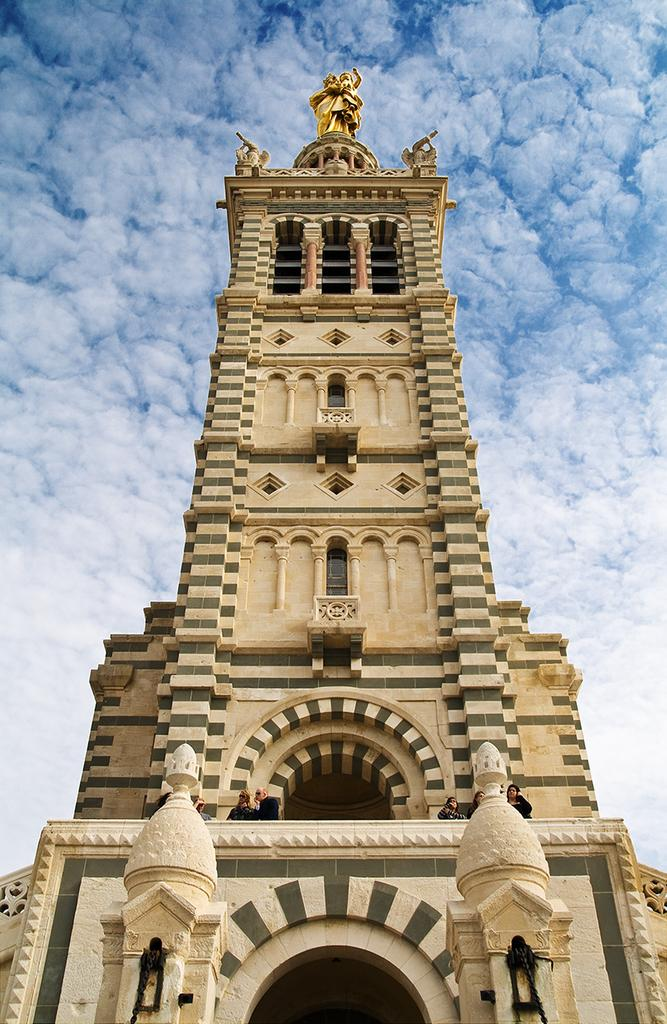What is the main structure in the image? There is a building in the middle of the image. What is on top of the building? There is a statue on the building. What can be seen in the sky in the image? There are clouds in the sky. What part of the sky is visible in the image? The sky is visible in the background of the image. What type of reaction can be seen from the flag in the image? There is no flag present in the image, so it is not possible to determine any reaction from a flag. 